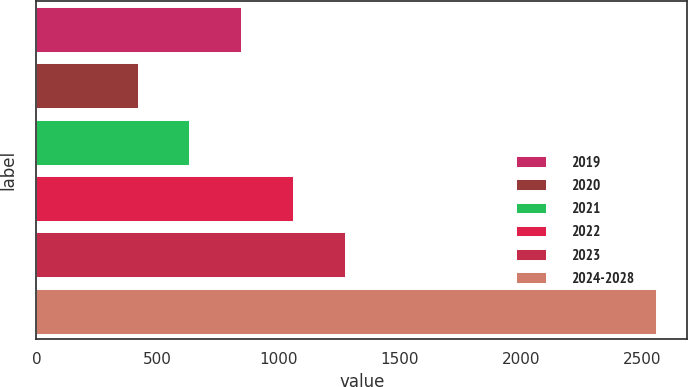Convert chart to OTSL. <chart><loc_0><loc_0><loc_500><loc_500><bar_chart><fcel>2019<fcel>2020<fcel>2021<fcel>2022<fcel>2023<fcel>2024-2028<nl><fcel>845<fcel>417<fcel>631<fcel>1059<fcel>1273<fcel>2557<nl></chart> 